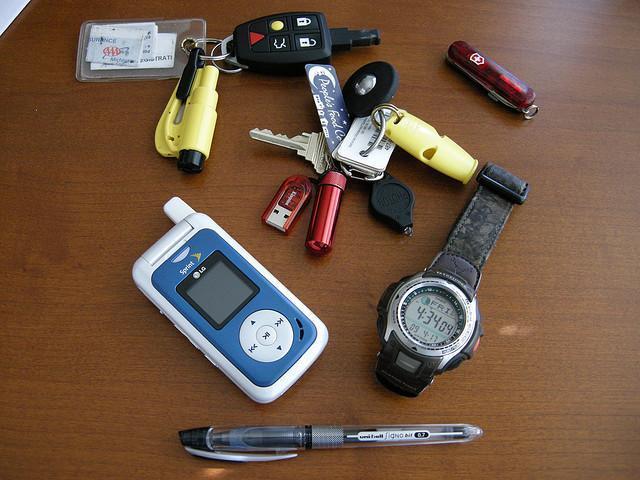How many of the dogs are black?
Give a very brief answer. 0. 